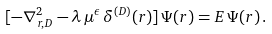Convert formula to latex. <formula><loc_0><loc_0><loc_500><loc_500>[ - \nabla _ { { r } , D } ^ { 2 } - \lambda \, \mu ^ { \epsilon } \, \delta ^ { ( { D } ) } ( { r } ) ] \, \Psi ( { r } ) = E \, \Psi ( { r } ) \, .</formula> 